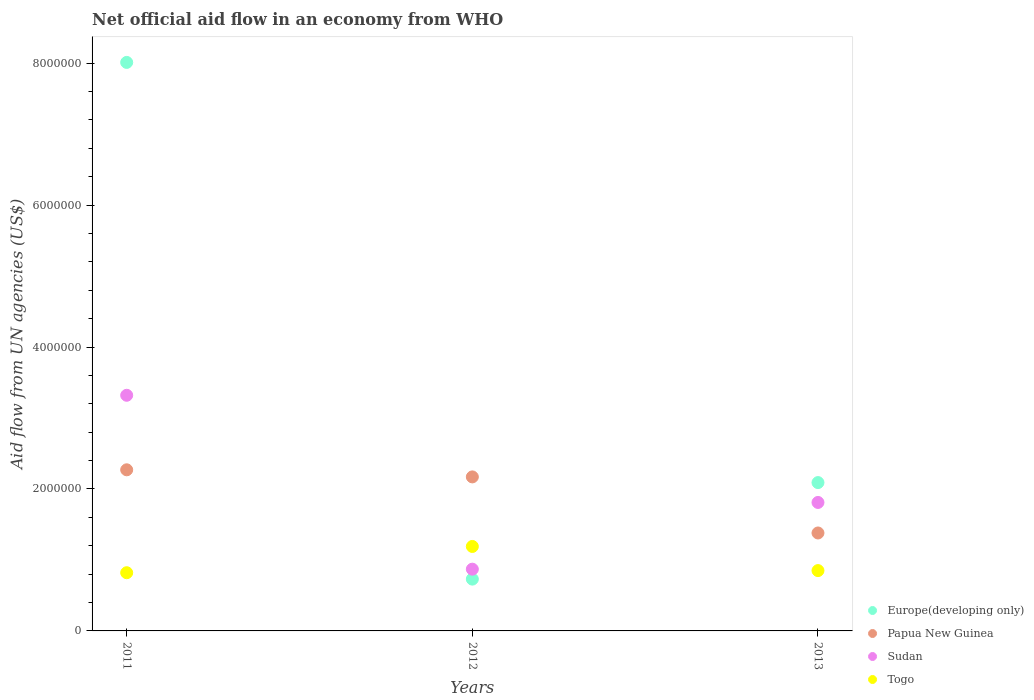How many different coloured dotlines are there?
Your answer should be compact. 4. Is the number of dotlines equal to the number of legend labels?
Your answer should be compact. Yes. What is the net official aid flow in Sudan in 2011?
Provide a short and direct response. 3.32e+06. Across all years, what is the maximum net official aid flow in Togo?
Provide a short and direct response. 1.19e+06. Across all years, what is the minimum net official aid flow in Papua New Guinea?
Offer a terse response. 1.38e+06. In which year was the net official aid flow in Sudan maximum?
Provide a short and direct response. 2011. What is the total net official aid flow in Togo in the graph?
Offer a very short reply. 2.86e+06. What is the difference between the net official aid flow in Togo in 2011 and that in 2012?
Offer a terse response. -3.70e+05. What is the difference between the net official aid flow in Sudan in 2011 and the net official aid flow in Togo in 2013?
Provide a short and direct response. 2.47e+06. What is the average net official aid flow in Togo per year?
Keep it short and to the point. 9.53e+05. In the year 2011, what is the difference between the net official aid flow in Papua New Guinea and net official aid flow in Sudan?
Make the answer very short. -1.05e+06. In how many years, is the net official aid flow in Papua New Guinea greater than 800000 US$?
Offer a terse response. 3. What is the ratio of the net official aid flow in Sudan in 2012 to that in 2013?
Give a very brief answer. 0.48. Is the net official aid flow in Europe(developing only) in 2011 less than that in 2013?
Give a very brief answer. No. Is the difference between the net official aid flow in Papua New Guinea in 2012 and 2013 greater than the difference between the net official aid flow in Sudan in 2012 and 2013?
Offer a terse response. Yes. What is the difference between the highest and the lowest net official aid flow in Togo?
Keep it short and to the point. 3.70e+05. Is the sum of the net official aid flow in Sudan in 2011 and 2013 greater than the maximum net official aid flow in Togo across all years?
Provide a succinct answer. Yes. Is it the case that in every year, the sum of the net official aid flow in Sudan and net official aid flow in Togo  is greater than the net official aid flow in Papua New Guinea?
Provide a succinct answer. No. Is the net official aid flow in Sudan strictly greater than the net official aid flow in Togo over the years?
Provide a short and direct response. No. Are the values on the major ticks of Y-axis written in scientific E-notation?
Give a very brief answer. No. Does the graph contain grids?
Keep it short and to the point. No. How many legend labels are there?
Offer a very short reply. 4. What is the title of the graph?
Provide a short and direct response. Net official aid flow in an economy from WHO. Does "Egypt, Arab Rep." appear as one of the legend labels in the graph?
Ensure brevity in your answer.  No. What is the label or title of the X-axis?
Offer a terse response. Years. What is the label or title of the Y-axis?
Provide a succinct answer. Aid flow from UN agencies (US$). What is the Aid flow from UN agencies (US$) of Europe(developing only) in 2011?
Keep it short and to the point. 8.01e+06. What is the Aid flow from UN agencies (US$) in Papua New Guinea in 2011?
Keep it short and to the point. 2.27e+06. What is the Aid flow from UN agencies (US$) in Sudan in 2011?
Provide a succinct answer. 3.32e+06. What is the Aid flow from UN agencies (US$) in Togo in 2011?
Your answer should be very brief. 8.20e+05. What is the Aid flow from UN agencies (US$) of Europe(developing only) in 2012?
Ensure brevity in your answer.  7.30e+05. What is the Aid flow from UN agencies (US$) of Papua New Guinea in 2012?
Provide a short and direct response. 2.17e+06. What is the Aid flow from UN agencies (US$) of Sudan in 2012?
Keep it short and to the point. 8.70e+05. What is the Aid flow from UN agencies (US$) in Togo in 2012?
Make the answer very short. 1.19e+06. What is the Aid flow from UN agencies (US$) of Europe(developing only) in 2013?
Provide a short and direct response. 2.09e+06. What is the Aid flow from UN agencies (US$) of Papua New Guinea in 2013?
Offer a very short reply. 1.38e+06. What is the Aid flow from UN agencies (US$) of Sudan in 2013?
Keep it short and to the point. 1.81e+06. What is the Aid flow from UN agencies (US$) in Togo in 2013?
Your answer should be very brief. 8.50e+05. Across all years, what is the maximum Aid flow from UN agencies (US$) of Europe(developing only)?
Your answer should be very brief. 8.01e+06. Across all years, what is the maximum Aid flow from UN agencies (US$) in Papua New Guinea?
Your answer should be very brief. 2.27e+06. Across all years, what is the maximum Aid flow from UN agencies (US$) of Sudan?
Offer a very short reply. 3.32e+06. Across all years, what is the maximum Aid flow from UN agencies (US$) of Togo?
Provide a succinct answer. 1.19e+06. Across all years, what is the minimum Aid flow from UN agencies (US$) in Europe(developing only)?
Make the answer very short. 7.30e+05. Across all years, what is the minimum Aid flow from UN agencies (US$) in Papua New Guinea?
Give a very brief answer. 1.38e+06. Across all years, what is the minimum Aid flow from UN agencies (US$) of Sudan?
Your response must be concise. 8.70e+05. Across all years, what is the minimum Aid flow from UN agencies (US$) of Togo?
Ensure brevity in your answer.  8.20e+05. What is the total Aid flow from UN agencies (US$) of Europe(developing only) in the graph?
Keep it short and to the point. 1.08e+07. What is the total Aid flow from UN agencies (US$) in Papua New Guinea in the graph?
Provide a succinct answer. 5.82e+06. What is the total Aid flow from UN agencies (US$) of Sudan in the graph?
Your answer should be very brief. 6.00e+06. What is the total Aid flow from UN agencies (US$) of Togo in the graph?
Offer a very short reply. 2.86e+06. What is the difference between the Aid flow from UN agencies (US$) in Europe(developing only) in 2011 and that in 2012?
Give a very brief answer. 7.28e+06. What is the difference between the Aid flow from UN agencies (US$) of Sudan in 2011 and that in 2012?
Make the answer very short. 2.45e+06. What is the difference between the Aid flow from UN agencies (US$) in Togo in 2011 and that in 2012?
Your answer should be very brief. -3.70e+05. What is the difference between the Aid flow from UN agencies (US$) in Europe(developing only) in 2011 and that in 2013?
Give a very brief answer. 5.92e+06. What is the difference between the Aid flow from UN agencies (US$) in Papua New Guinea in 2011 and that in 2013?
Provide a short and direct response. 8.90e+05. What is the difference between the Aid flow from UN agencies (US$) in Sudan in 2011 and that in 2013?
Offer a terse response. 1.51e+06. What is the difference between the Aid flow from UN agencies (US$) of Europe(developing only) in 2012 and that in 2013?
Provide a succinct answer. -1.36e+06. What is the difference between the Aid flow from UN agencies (US$) in Papua New Guinea in 2012 and that in 2013?
Your answer should be compact. 7.90e+05. What is the difference between the Aid flow from UN agencies (US$) in Sudan in 2012 and that in 2013?
Make the answer very short. -9.40e+05. What is the difference between the Aid flow from UN agencies (US$) in Togo in 2012 and that in 2013?
Your response must be concise. 3.40e+05. What is the difference between the Aid flow from UN agencies (US$) of Europe(developing only) in 2011 and the Aid flow from UN agencies (US$) of Papua New Guinea in 2012?
Offer a terse response. 5.84e+06. What is the difference between the Aid flow from UN agencies (US$) in Europe(developing only) in 2011 and the Aid flow from UN agencies (US$) in Sudan in 2012?
Make the answer very short. 7.14e+06. What is the difference between the Aid flow from UN agencies (US$) in Europe(developing only) in 2011 and the Aid flow from UN agencies (US$) in Togo in 2012?
Provide a short and direct response. 6.82e+06. What is the difference between the Aid flow from UN agencies (US$) in Papua New Guinea in 2011 and the Aid flow from UN agencies (US$) in Sudan in 2012?
Ensure brevity in your answer.  1.40e+06. What is the difference between the Aid flow from UN agencies (US$) in Papua New Guinea in 2011 and the Aid flow from UN agencies (US$) in Togo in 2012?
Offer a very short reply. 1.08e+06. What is the difference between the Aid flow from UN agencies (US$) of Sudan in 2011 and the Aid flow from UN agencies (US$) of Togo in 2012?
Your answer should be very brief. 2.13e+06. What is the difference between the Aid flow from UN agencies (US$) in Europe(developing only) in 2011 and the Aid flow from UN agencies (US$) in Papua New Guinea in 2013?
Make the answer very short. 6.63e+06. What is the difference between the Aid flow from UN agencies (US$) of Europe(developing only) in 2011 and the Aid flow from UN agencies (US$) of Sudan in 2013?
Offer a very short reply. 6.20e+06. What is the difference between the Aid flow from UN agencies (US$) of Europe(developing only) in 2011 and the Aid flow from UN agencies (US$) of Togo in 2013?
Provide a succinct answer. 7.16e+06. What is the difference between the Aid flow from UN agencies (US$) in Papua New Guinea in 2011 and the Aid flow from UN agencies (US$) in Togo in 2013?
Your response must be concise. 1.42e+06. What is the difference between the Aid flow from UN agencies (US$) in Sudan in 2011 and the Aid flow from UN agencies (US$) in Togo in 2013?
Offer a very short reply. 2.47e+06. What is the difference between the Aid flow from UN agencies (US$) of Europe(developing only) in 2012 and the Aid flow from UN agencies (US$) of Papua New Guinea in 2013?
Give a very brief answer. -6.50e+05. What is the difference between the Aid flow from UN agencies (US$) of Europe(developing only) in 2012 and the Aid flow from UN agencies (US$) of Sudan in 2013?
Offer a terse response. -1.08e+06. What is the difference between the Aid flow from UN agencies (US$) of Europe(developing only) in 2012 and the Aid flow from UN agencies (US$) of Togo in 2013?
Keep it short and to the point. -1.20e+05. What is the difference between the Aid flow from UN agencies (US$) of Papua New Guinea in 2012 and the Aid flow from UN agencies (US$) of Togo in 2013?
Your answer should be compact. 1.32e+06. What is the difference between the Aid flow from UN agencies (US$) of Sudan in 2012 and the Aid flow from UN agencies (US$) of Togo in 2013?
Give a very brief answer. 2.00e+04. What is the average Aid flow from UN agencies (US$) of Europe(developing only) per year?
Keep it short and to the point. 3.61e+06. What is the average Aid flow from UN agencies (US$) in Papua New Guinea per year?
Ensure brevity in your answer.  1.94e+06. What is the average Aid flow from UN agencies (US$) of Togo per year?
Ensure brevity in your answer.  9.53e+05. In the year 2011, what is the difference between the Aid flow from UN agencies (US$) in Europe(developing only) and Aid flow from UN agencies (US$) in Papua New Guinea?
Ensure brevity in your answer.  5.74e+06. In the year 2011, what is the difference between the Aid flow from UN agencies (US$) in Europe(developing only) and Aid flow from UN agencies (US$) in Sudan?
Ensure brevity in your answer.  4.69e+06. In the year 2011, what is the difference between the Aid flow from UN agencies (US$) in Europe(developing only) and Aid flow from UN agencies (US$) in Togo?
Provide a short and direct response. 7.19e+06. In the year 2011, what is the difference between the Aid flow from UN agencies (US$) of Papua New Guinea and Aid flow from UN agencies (US$) of Sudan?
Your response must be concise. -1.05e+06. In the year 2011, what is the difference between the Aid flow from UN agencies (US$) of Papua New Guinea and Aid flow from UN agencies (US$) of Togo?
Ensure brevity in your answer.  1.45e+06. In the year 2011, what is the difference between the Aid flow from UN agencies (US$) in Sudan and Aid flow from UN agencies (US$) in Togo?
Give a very brief answer. 2.50e+06. In the year 2012, what is the difference between the Aid flow from UN agencies (US$) of Europe(developing only) and Aid flow from UN agencies (US$) of Papua New Guinea?
Your answer should be very brief. -1.44e+06. In the year 2012, what is the difference between the Aid flow from UN agencies (US$) in Europe(developing only) and Aid flow from UN agencies (US$) in Sudan?
Ensure brevity in your answer.  -1.40e+05. In the year 2012, what is the difference between the Aid flow from UN agencies (US$) of Europe(developing only) and Aid flow from UN agencies (US$) of Togo?
Your answer should be very brief. -4.60e+05. In the year 2012, what is the difference between the Aid flow from UN agencies (US$) of Papua New Guinea and Aid flow from UN agencies (US$) of Sudan?
Your answer should be very brief. 1.30e+06. In the year 2012, what is the difference between the Aid flow from UN agencies (US$) in Papua New Guinea and Aid flow from UN agencies (US$) in Togo?
Keep it short and to the point. 9.80e+05. In the year 2012, what is the difference between the Aid flow from UN agencies (US$) in Sudan and Aid flow from UN agencies (US$) in Togo?
Give a very brief answer. -3.20e+05. In the year 2013, what is the difference between the Aid flow from UN agencies (US$) in Europe(developing only) and Aid flow from UN agencies (US$) in Papua New Guinea?
Provide a short and direct response. 7.10e+05. In the year 2013, what is the difference between the Aid flow from UN agencies (US$) in Europe(developing only) and Aid flow from UN agencies (US$) in Togo?
Keep it short and to the point. 1.24e+06. In the year 2013, what is the difference between the Aid flow from UN agencies (US$) in Papua New Guinea and Aid flow from UN agencies (US$) in Sudan?
Your response must be concise. -4.30e+05. In the year 2013, what is the difference between the Aid flow from UN agencies (US$) of Papua New Guinea and Aid flow from UN agencies (US$) of Togo?
Keep it short and to the point. 5.30e+05. In the year 2013, what is the difference between the Aid flow from UN agencies (US$) of Sudan and Aid flow from UN agencies (US$) of Togo?
Provide a short and direct response. 9.60e+05. What is the ratio of the Aid flow from UN agencies (US$) of Europe(developing only) in 2011 to that in 2012?
Your answer should be very brief. 10.97. What is the ratio of the Aid flow from UN agencies (US$) in Papua New Guinea in 2011 to that in 2012?
Keep it short and to the point. 1.05. What is the ratio of the Aid flow from UN agencies (US$) in Sudan in 2011 to that in 2012?
Provide a succinct answer. 3.82. What is the ratio of the Aid flow from UN agencies (US$) of Togo in 2011 to that in 2012?
Make the answer very short. 0.69. What is the ratio of the Aid flow from UN agencies (US$) of Europe(developing only) in 2011 to that in 2013?
Give a very brief answer. 3.83. What is the ratio of the Aid flow from UN agencies (US$) of Papua New Guinea in 2011 to that in 2013?
Offer a very short reply. 1.64. What is the ratio of the Aid flow from UN agencies (US$) of Sudan in 2011 to that in 2013?
Ensure brevity in your answer.  1.83. What is the ratio of the Aid flow from UN agencies (US$) in Togo in 2011 to that in 2013?
Your answer should be very brief. 0.96. What is the ratio of the Aid flow from UN agencies (US$) of Europe(developing only) in 2012 to that in 2013?
Your answer should be compact. 0.35. What is the ratio of the Aid flow from UN agencies (US$) of Papua New Guinea in 2012 to that in 2013?
Make the answer very short. 1.57. What is the ratio of the Aid flow from UN agencies (US$) of Sudan in 2012 to that in 2013?
Your answer should be very brief. 0.48. What is the difference between the highest and the second highest Aid flow from UN agencies (US$) of Europe(developing only)?
Give a very brief answer. 5.92e+06. What is the difference between the highest and the second highest Aid flow from UN agencies (US$) in Papua New Guinea?
Provide a succinct answer. 1.00e+05. What is the difference between the highest and the second highest Aid flow from UN agencies (US$) of Sudan?
Make the answer very short. 1.51e+06. What is the difference between the highest and the lowest Aid flow from UN agencies (US$) in Europe(developing only)?
Provide a short and direct response. 7.28e+06. What is the difference between the highest and the lowest Aid flow from UN agencies (US$) of Papua New Guinea?
Offer a terse response. 8.90e+05. What is the difference between the highest and the lowest Aid flow from UN agencies (US$) in Sudan?
Offer a very short reply. 2.45e+06. What is the difference between the highest and the lowest Aid flow from UN agencies (US$) in Togo?
Your answer should be compact. 3.70e+05. 